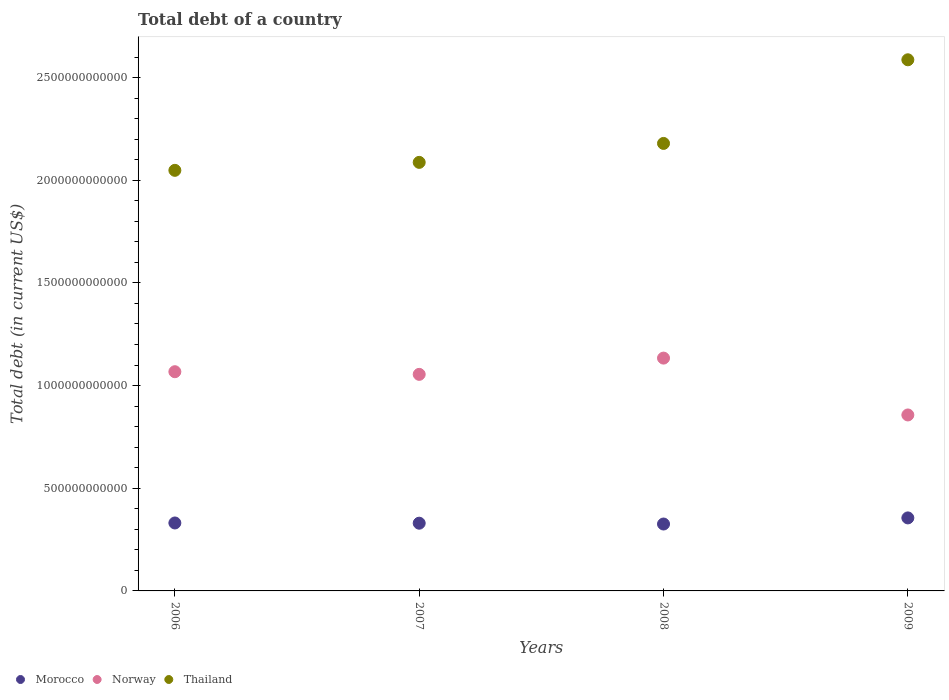What is the debt in Norway in 2009?
Make the answer very short. 8.57e+11. Across all years, what is the maximum debt in Norway?
Offer a terse response. 1.13e+12. Across all years, what is the minimum debt in Morocco?
Your answer should be very brief. 3.26e+11. In which year was the debt in Norway maximum?
Your answer should be very brief. 2008. What is the total debt in Thailand in the graph?
Your response must be concise. 8.90e+12. What is the difference between the debt in Thailand in 2008 and that in 2009?
Keep it short and to the point. -4.07e+11. What is the difference between the debt in Morocco in 2007 and the debt in Thailand in 2008?
Provide a succinct answer. -1.85e+12. What is the average debt in Morocco per year?
Give a very brief answer. 3.36e+11. In the year 2007, what is the difference between the debt in Thailand and debt in Norway?
Your response must be concise. 1.03e+12. In how many years, is the debt in Thailand greater than 500000000000 US$?
Offer a terse response. 4. What is the ratio of the debt in Thailand in 2007 to that in 2009?
Keep it short and to the point. 0.81. Is the debt in Morocco in 2007 less than that in 2009?
Ensure brevity in your answer.  Yes. Is the difference between the debt in Thailand in 2006 and 2007 greater than the difference between the debt in Norway in 2006 and 2007?
Ensure brevity in your answer.  No. What is the difference between the highest and the second highest debt in Morocco?
Keep it short and to the point. 2.47e+1. What is the difference between the highest and the lowest debt in Norway?
Your answer should be compact. 2.77e+11. Is it the case that in every year, the sum of the debt in Thailand and debt in Morocco  is greater than the debt in Norway?
Provide a short and direct response. Yes. Is the debt in Norway strictly greater than the debt in Thailand over the years?
Provide a succinct answer. No. Is the debt in Morocco strictly less than the debt in Thailand over the years?
Your response must be concise. Yes. What is the difference between two consecutive major ticks on the Y-axis?
Provide a short and direct response. 5.00e+11. How many legend labels are there?
Your response must be concise. 3. What is the title of the graph?
Provide a succinct answer. Total debt of a country. Does "Israel" appear as one of the legend labels in the graph?
Provide a succinct answer. No. What is the label or title of the Y-axis?
Provide a succinct answer. Total debt (in current US$). What is the Total debt (in current US$) of Morocco in 2006?
Offer a terse response. 3.31e+11. What is the Total debt (in current US$) in Norway in 2006?
Provide a succinct answer. 1.07e+12. What is the Total debt (in current US$) of Thailand in 2006?
Your answer should be compact. 2.05e+12. What is the Total debt (in current US$) of Morocco in 2007?
Your response must be concise. 3.30e+11. What is the Total debt (in current US$) in Norway in 2007?
Your answer should be compact. 1.05e+12. What is the Total debt (in current US$) of Thailand in 2007?
Ensure brevity in your answer.  2.09e+12. What is the Total debt (in current US$) in Morocco in 2008?
Provide a succinct answer. 3.26e+11. What is the Total debt (in current US$) in Norway in 2008?
Provide a short and direct response. 1.13e+12. What is the Total debt (in current US$) in Thailand in 2008?
Your answer should be compact. 2.18e+12. What is the Total debt (in current US$) in Morocco in 2009?
Keep it short and to the point. 3.56e+11. What is the Total debt (in current US$) of Norway in 2009?
Your response must be concise. 8.57e+11. What is the Total debt (in current US$) of Thailand in 2009?
Offer a very short reply. 2.59e+12. Across all years, what is the maximum Total debt (in current US$) of Morocco?
Give a very brief answer. 3.56e+11. Across all years, what is the maximum Total debt (in current US$) of Norway?
Your answer should be very brief. 1.13e+12. Across all years, what is the maximum Total debt (in current US$) in Thailand?
Ensure brevity in your answer.  2.59e+12. Across all years, what is the minimum Total debt (in current US$) of Morocco?
Offer a terse response. 3.26e+11. Across all years, what is the minimum Total debt (in current US$) in Norway?
Your answer should be very brief. 8.57e+11. Across all years, what is the minimum Total debt (in current US$) of Thailand?
Make the answer very short. 2.05e+12. What is the total Total debt (in current US$) of Morocco in the graph?
Your answer should be compact. 1.34e+12. What is the total Total debt (in current US$) in Norway in the graph?
Keep it short and to the point. 4.11e+12. What is the total Total debt (in current US$) in Thailand in the graph?
Your answer should be compact. 8.90e+12. What is the difference between the Total debt (in current US$) in Morocco in 2006 and that in 2007?
Offer a terse response. 1.06e+09. What is the difference between the Total debt (in current US$) of Norway in 2006 and that in 2007?
Offer a very short reply. 1.29e+1. What is the difference between the Total debt (in current US$) of Thailand in 2006 and that in 2007?
Your response must be concise. -3.88e+1. What is the difference between the Total debt (in current US$) in Morocco in 2006 and that in 2008?
Provide a short and direct response. 5.08e+09. What is the difference between the Total debt (in current US$) of Norway in 2006 and that in 2008?
Provide a succinct answer. -6.62e+1. What is the difference between the Total debt (in current US$) in Thailand in 2006 and that in 2008?
Give a very brief answer. -1.31e+11. What is the difference between the Total debt (in current US$) of Morocco in 2006 and that in 2009?
Provide a short and direct response. -2.47e+1. What is the difference between the Total debt (in current US$) in Norway in 2006 and that in 2009?
Offer a terse response. 2.11e+11. What is the difference between the Total debt (in current US$) of Thailand in 2006 and that in 2009?
Offer a terse response. -5.38e+11. What is the difference between the Total debt (in current US$) of Morocco in 2007 and that in 2008?
Your answer should be very brief. 4.02e+09. What is the difference between the Total debt (in current US$) in Norway in 2007 and that in 2008?
Make the answer very short. -7.91e+1. What is the difference between the Total debt (in current US$) in Thailand in 2007 and that in 2008?
Give a very brief answer. -9.23e+1. What is the difference between the Total debt (in current US$) of Morocco in 2007 and that in 2009?
Give a very brief answer. -2.57e+1. What is the difference between the Total debt (in current US$) of Norway in 2007 and that in 2009?
Keep it short and to the point. 1.98e+11. What is the difference between the Total debt (in current US$) of Thailand in 2007 and that in 2009?
Make the answer very short. -5.00e+11. What is the difference between the Total debt (in current US$) of Morocco in 2008 and that in 2009?
Make the answer very short. -2.98e+1. What is the difference between the Total debt (in current US$) in Norway in 2008 and that in 2009?
Provide a short and direct response. 2.77e+11. What is the difference between the Total debt (in current US$) in Thailand in 2008 and that in 2009?
Ensure brevity in your answer.  -4.07e+11. What is the difference between the Total debt (in current US$) in Morocco in 2006 and the Total debt (in current US$) in Norway in 2007?
Make the answer very short. -7.24e+11. What is the difference between the Total debt (in current US$) in Morocco in 2006 and the Total debt (in current US$) in Thailand in 2007?
Your answer should be very brief. -1.76e+12. What is the difference between the Total debt (in current US$) in Norway in 2006 and the Total debt (in current US$) in Thailand in 2007?
Make the answer very short. -1.02e+12. What is the difference between the Total debt (in current US$) in Morocco in 2006 and the Total debt (in current US$) in Norway in 2008?
Your answer should be compact. -8.03e+11. What is the difference between the Total debt (in current US$) in Morocco in 2006 and the Total debt (in current US$) in Thailand in 2008?
Offer a very short reply. -1.85e+12. What is the difference between the Total debt (in current US$) of Norway in 2006 and the Total debt (in current US$) of Thailand in 2008?
Ensure brevity in your answer.  -1.11e+12. What is the difference between the Total debt (in current US$) in Morocco in 2006 and the Total debt (in current US$) in Norway in 2009?
Make the answer very short. -5.26e+11. What is the difference between the Total debt (in current US$) in Morocco in 2006 and the Total debt (in current US$) in Thailand in 2009?
Your answer should be very brief. -2.26e+12. What is the difference between the Total debt (in current US$) in Norway in 2006 and the Total debt (in current US$) in Thailand in 2009?
Make the answer very short. -1.52e+12. What is the difference between the Total debt (in current US$) in Morocco in 2007 and the Total debt (in current US$) in Norway in 2008?
Your answer should be very brief. -8.04e+11. What is the difference between the Total debt (in current US$) of Morocco in 2007 and the Total debt (in current US$) of Thailand in 2008?
Give a very brief answer. -1.85e+12. What is the difference between the Total debt (in current US$) of Norway in 2007 and the Total debt (in current US$) of Thailand in 2008?
Offer a very short reply. -1.12e+12. What is the difference between the Total debt (in current US$) in Morocco in 2007 and the Total debt (in current US$) in Norway in 2009?
Provide a succinct answer. -5.27e+11. What is the difference between the Total debt (in current US$) in Morocco in 2007 and the Total debt (in current US$) in Thailand in 2009?
Offer a terse response. -2.26e+12. What is the difference between the Total debt (in current US$) in Norway in 2007 and the Total debt (in current US$) in Thailand in 2009?
Provide a short and direct response. -1.53e+12. What is the difference between the Total debt (in current US$) of Morocco in 2008 and the Total debt (in current US$) of Norway in 2009?
Give a very brief answer. -5.31e+11. What is the difference between the Total debt (in current US$) of Morocco in 2008 and the Total debt (in current US$) of Thailand in 2009?
Give a very brief answer. -2.26e+12. What is the difference between the Total debt (in current US$) in Norway in 2008 and the Total debt (in current US$) in Thailand in 2009?
Give a very brief answer. -1.45e+12. What is the average Total debt (in current US$) in Morocco per year?
Offer a very short reply. 3.36e+11. What is the average Total debt (in current US$) of Norway per year?
Ensure brevity in your answer.  1.03e+12. What is the average Total debt (in current US$) in Thailand per year?
Your answer should be compact. 2.23e+12. In the year 2006, what is the difference between the Total debt (in current US$) of Morocco and Total debt (in current US$) of Norway?
Your answer should be compact. -7.37e+11. In the year 2006, what is the difference between the Total debt (in current US$) of Morocco and Total debt (in current US$) of Thailand?
Offer a very short reply. -1.72e+12. In the year 2006, what is the difference between the Total debt (in current US$) of Norway and Total debt (in current US$) of Thailand?
Provide a short and direct response. -9.81e+11. In the year 2007, what is the difference between the Total debt (in current US$) in Morocco and Total debt (in current US$) in Norway?
Your answer should be very brief. -7.25e+11. In the year 2007, what is the difference between the Total debt (in current US$) of Morocco and Total debt (in current US$) of Thailand?
Offer a very short reply. -1.76e+12. In the year 2007, what is the difference between the Total debt (in current US$) in Norway and Total debt (in current US$) in Thailand?
Ensure brevity in your answer.  -1.03e+12. In the year 2008, what is the difference between the Total debt (in current US$) in Morocco and Total debt (in current US$) in Norway?
Make the answer very short. -8.08e+11. In the year 2008, what is the difference between the Total debt (in current US$) in Morocco and Total debt (in current US$) in Thailand?
Your response must be concise. -1.85e+12. In the year 2008, what is the difference between the Total debt (in current US$) in Norway and Total debt (in current US$) in Thailand?
Your answer should be very brief. -1.05e+12. In the year 2009, what is the difference between the Total debt (in current US$) in Morocco and Total debt (in current US$) in Norway?
Offer a terse response. -5.01e+11. In the year 2009, what is the difference between the Total debt (in current US$) in Morocco and Total debt (in current US$) in Thailand?
Provide a short and direct response. -2.23e+12. In the year 2009, what is the difference between the Total debt (in current US$) of Norway and Total debt (in current US$) of Thailand?
Your answer should be compact. -1.73e+12. What is the ratio of the Total debt (in current US$) in Norway in 2006 to that in 2007?
Provide a succinct answer. 1.01. What is the ratio of the Total debt (in current US$) of Thailand in 2006 to that in 2007?
Offer a terse response. 0.98. What is the ratio of the Total debt (in current US$) in Morocco in 2006 to that in 2008?
Offer a very short reply. 1.02. What is the ratio of the Total debt (in current US$) in Norway in 2006 to that in 2008?
Provide a short and direct response. 0.94. What is the ratio of the Total debt (in current US$) of Thailand in 2006 to that in 2008?
Give a very brief answer. 0.94. What is the ratio of the Total debt (in current US$) of Morocco in 2006 to that in 2009?
Provide a short and direct response. 0.93. What is the ratio of the Total debt (in current US$) in Norway in 2006 to that in 2009?
Give a very brief answer. 1.25. What is the ratio of the Total debt (in current US$) of Thailand in 2006 to that in 2009?
Provide a succinct answer. 0.79. What is the ratio of the Total debt (in current US$) in Morocco in 2007 to that in 2008?
Ensure brevity in your answer.  1.01. What is the ratio of the Total debt (in current US$) of Norway in 2007 to that in 2008?
Give a very brief answer. 0.93. What is the ratio of the Total debt (in current US$) of Thailand in 2007 to that in 2008?
Make the answer very short. 0.96. What is the ratio of the Total debt (in current US$) of Morocco in 2007 to that in 2009?
Your answer should be compact. 0.93. What is the ratio of the Total debt (in current US$) in Norway in 2007 to that in 2009?
Ensure brevity in your answer.  1.23. What is the ratio of the Total debt (in current US$) in Thailand in 2007 to that in 2009?
Your answer should be very brief. 0.81. What is the ratio of the Total debt (in current US$) in Morocco in 2008 to that in 2009?
Provide a succinct answer. 0.92. What is the ratio of the Total debt (in current US$) in Norway in 2008 to that in 2009?
Offer a very short reply. 1.32. What is the ratio of the Total debt (in current US$) in Thailand in 2008 to that in 2009?
Keep it short and to the point. 0.84. What is the difference between the highest and the second highest Total debt (in current US$) in Morocco?
Give a very brief answer. 2.47e+1. What is the difference between the highest and the second highest Total debt (in current US$) in Norway?
Your answer should be compact. 6.62e+1. What is the difference between the highest and the second highest Total debt (in current US$) of Thailand?
Offer a very short reply. 4.07e+11. What is the difference between the highest and the lowest Total debt (in current US$) in Morocco?
Ensure brevity in your answer.  2.98e+1. What is the difference between the highest and the lowest Total debt (in current US$) of Norway?
Ensure brevity in your answer.  2.77e+11. What is the difference between the highest and the lowest Total debt (in current US$) of Thailand?
Your answer should be compact. 5.38e+11. 